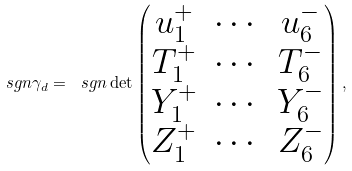Convert formula to latex. <formula><loc_0><loc_0><loc_500><loc_500>\ s g n \gamma _ { d } = \ s g n \det \begin{pmatrix} u _ { 1 } ^ { + } & \cdots & u _ { 6 } ^ { - } \\ T _ { 1 } ^ { + } & \cdots & T _ { 6 } ^ { - } \\ Y _ { 1 } ^ { + } & \cdots & Y _ { 6 } ^ { - } \\ Z _ { 1 } ^ { + } & \cdots & Z _ { 6 } ^ { - } \end{pmatrix} ,</formula> 